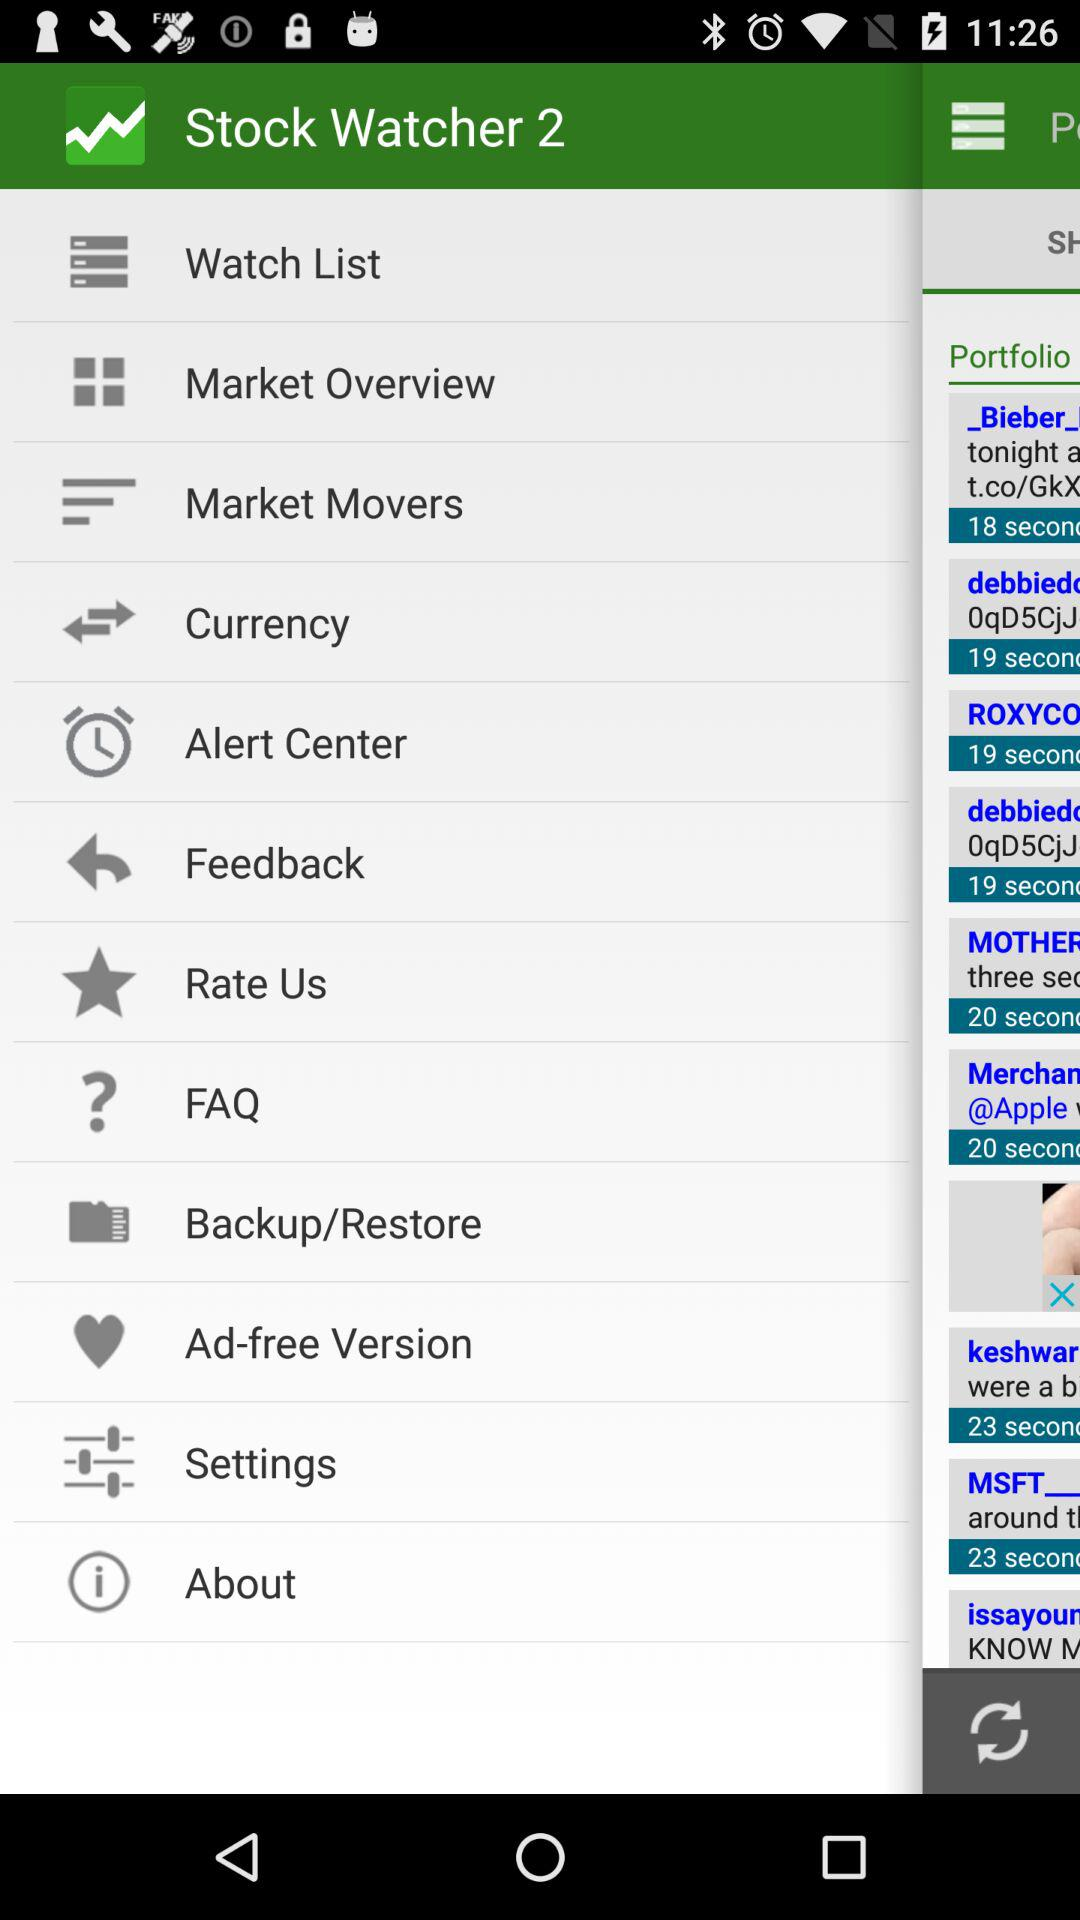What is the app name? The app name is "Stock Watcher 2". 